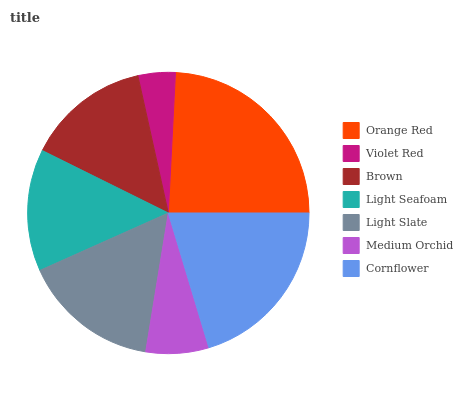Is Violet Red the minimum?
Answer yes or no. Yes. Is Orange Red the maximum?
Answer yes or no. Yes. Is Brown the minimum?
Answer yes or no. No. Is Brown the maximum?
Answer yes or no. No. Is Brown greater than Violet Red?
Answer yes or no. Yes. Is Violet Red less than Brown?
Answer yes or no. Yes. Is Violet Red greater than Brown?
Answer yes or no. No. Is Brown less than Violet Red?
Answer yes or no. No. Is Brown the high median?
Answer yes or no. Yes. Is Brown the low median?
Answer yes or no. Yes. Is Orange Red the high median?
Answer yes or no. No. Is Light Seafoam the low median?
Answer yes or no. No. 